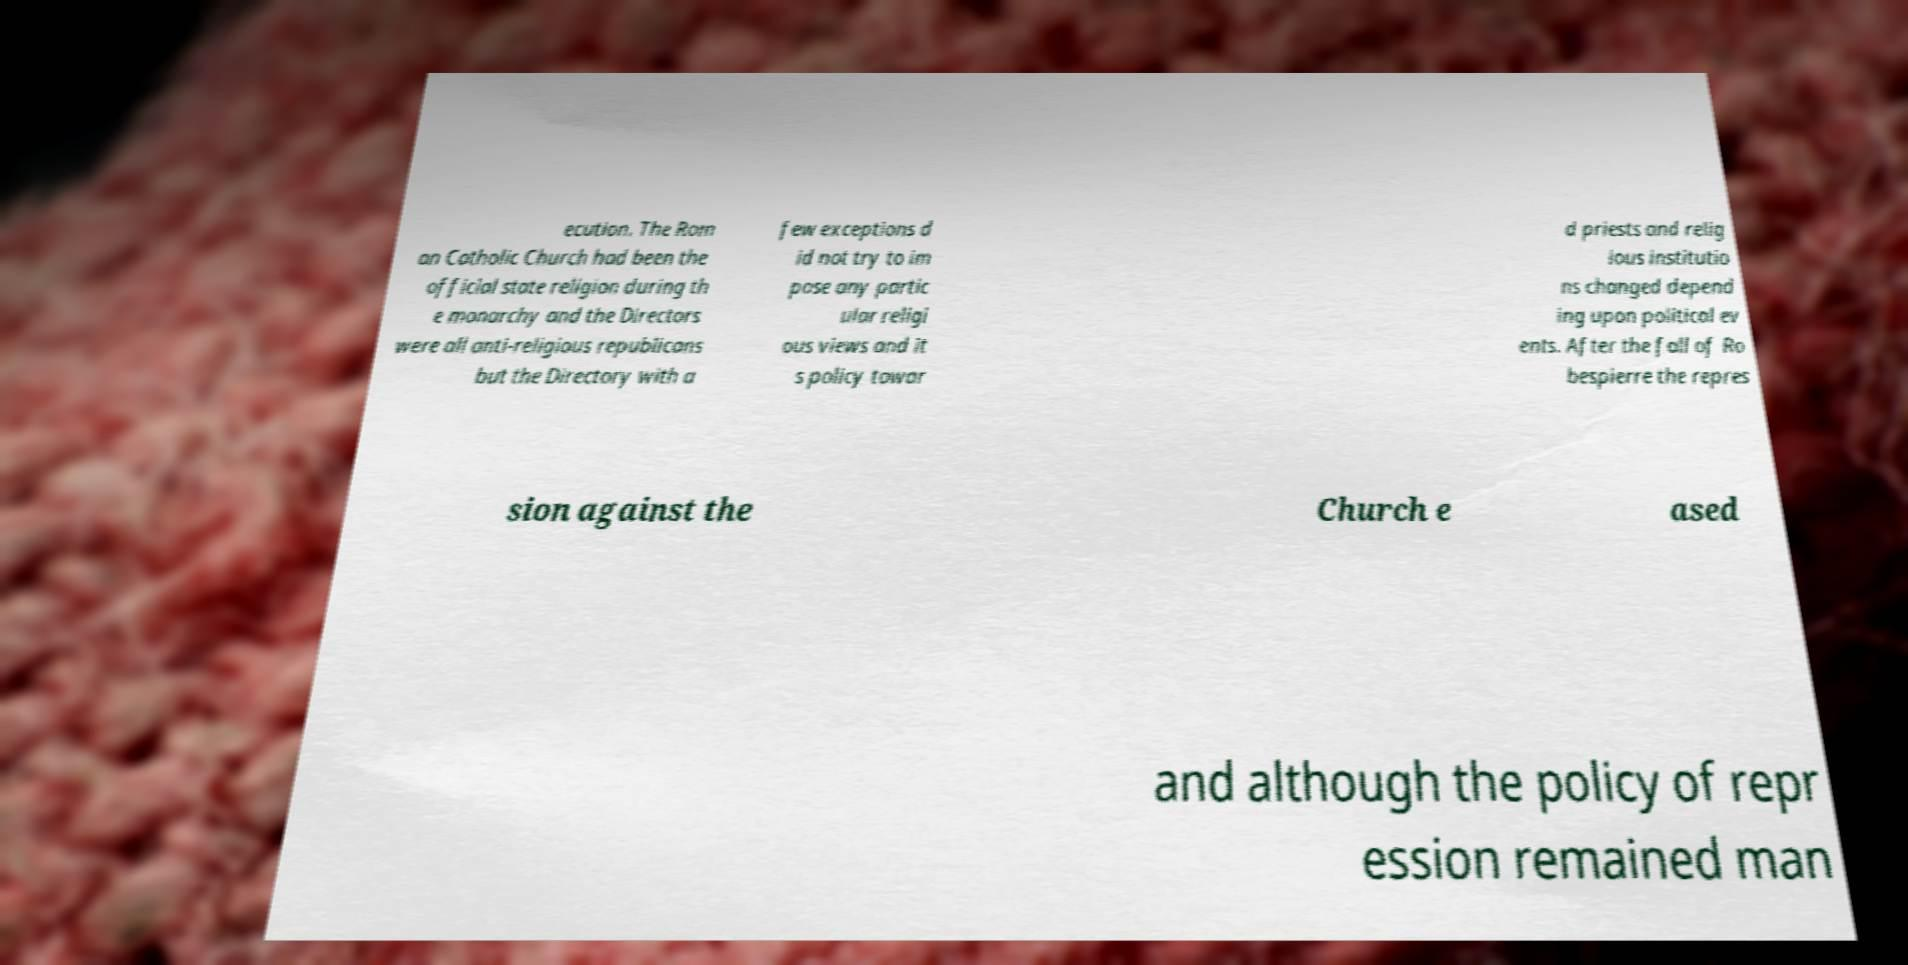Could you assist in decoding the text presented in this image and type it out clearly? ecution. The Rom an Catholic Church had been the official state religion during th e monarchy and the Directors were all anti-religious republicans but the Directory with a few exceptions d id not try to im pose any partic ular religi ous views and it s policy towar d priests and relig ious institutio ns changed depend ing upon political ev ents. After the fall of Ro bespierre the repres sion against the Church e ased and although the policy of repr ession remained man 